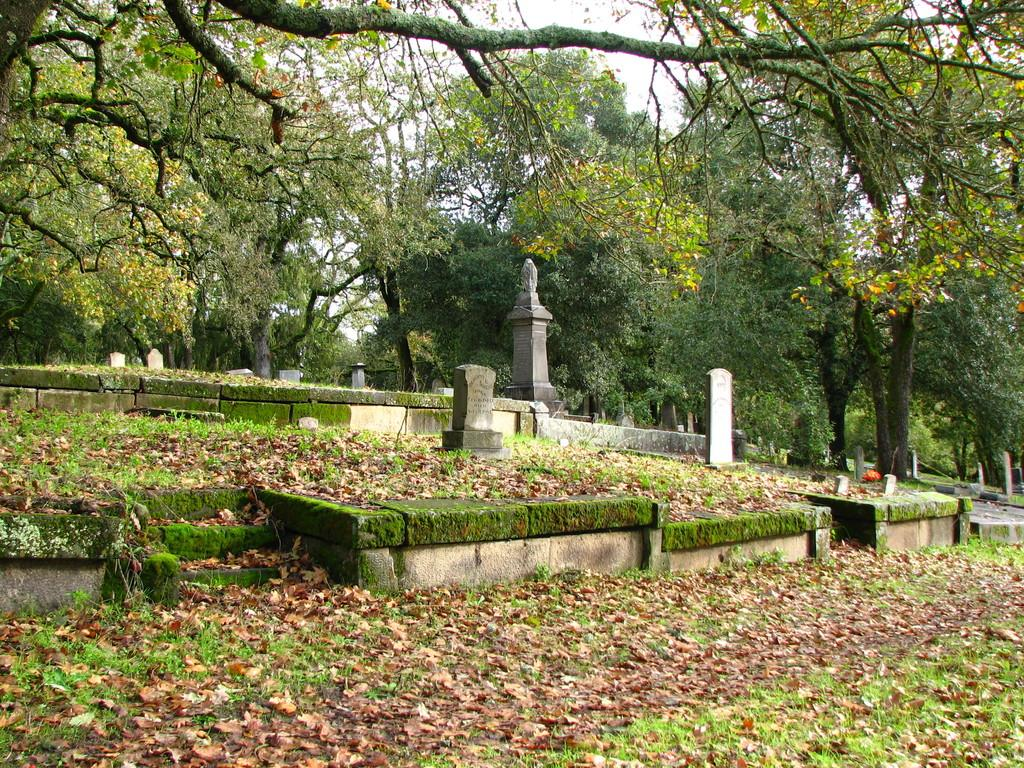What is the setting of the image? The image is taken in a graveyard. What can be seen in the image that is related to the graveyard? There are graves in the image. What is visible in the background of the image? There are trees in the background of the image. What is present at the bottom of the image? Leaves are visible at the bottom of the image. What type of instrument is being played by the person in the image? There is no person or instrument present in the image; it is a photograph of a graveyard with graves, trees, and leaves. 